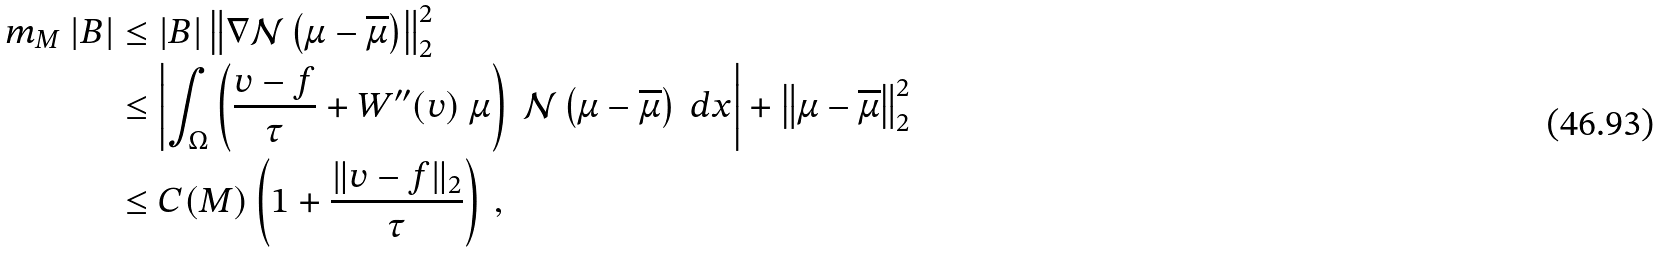Convert formula to latex. <formula><loc_0><loc_0><loc_500><loc_500>m _ { M } \ | B | & \leq | B | \left \| \nabla \mathcal { N } \left ( \mu - \overline { \mu } \right ) \right \| _ { 2 } ^ { 2 } \\ & \leq \left | \int _ { \Omega } \left ( \frac { v - f } { \tau } + W ^ { \prime \prime } ( v ) \ \mu \right ) \ \mathcal { N } \left ( \mu - \overline { \mu } \right ) \ d x \right | + \left \| \mu - \overline { \mu } \right \| _ { 2 } ^ { 2 } \\ & \leq C ( M ) \left ( 1 + \frac { \| v - f \| _ { 2 } } { \tau } \right ) \, ,</formula> 